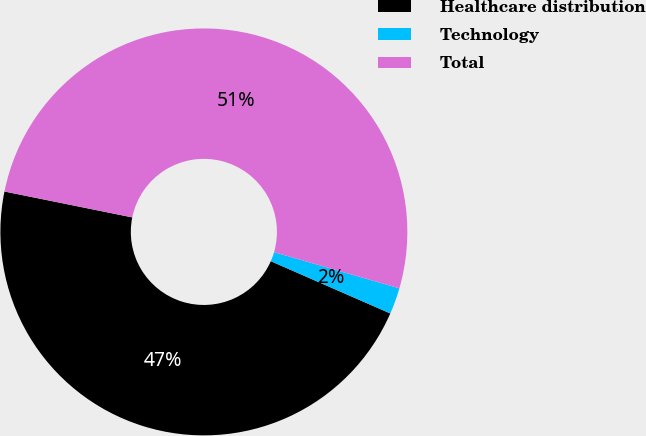<chart> <loc_0><loc_0><loc_500><loc_500><pie_chart><fcel>Healthcare distribution<fcel>Technology<fcel>Total<nl><fcel>46.62%<fcel>2.09%<fcel>51.29%<nl></chart> 